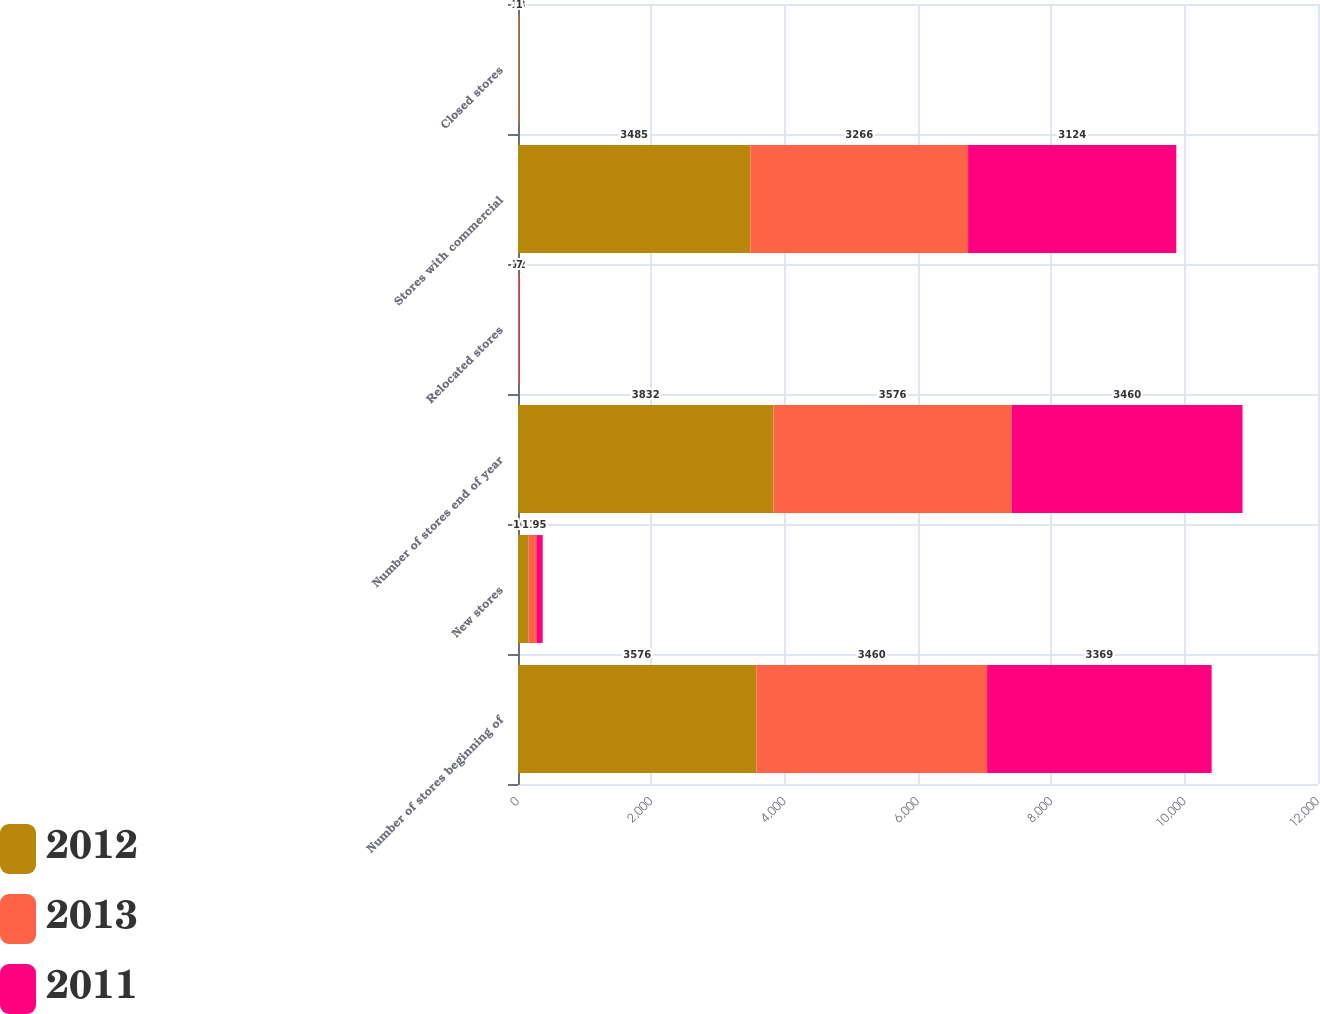Convert chart. <chart><loc_0><loc_0><loc_500><loc_500><stacked_bar_chart><ecel><fcel>Number of stores beginning of<fcel>New stores<fcel>Number of stores end of year<fcel>Relocated stores<fcel>Stores with commercial<fcel>Closed stores<nl><fcel>2012<fcel>3576<fcel>160<fcel>3832<fcel>6<fcel>3485<fcel>13<nl><fcel>2013<fcel>3460<fcel>116<fcel>3576<fcel>12<fcel>3266<fcel>5<nl><fcel>2011<fcel>3369<fcel>95<fcel>3460<fcel>7<fcel>3124<fcel>1<nl></chart> 